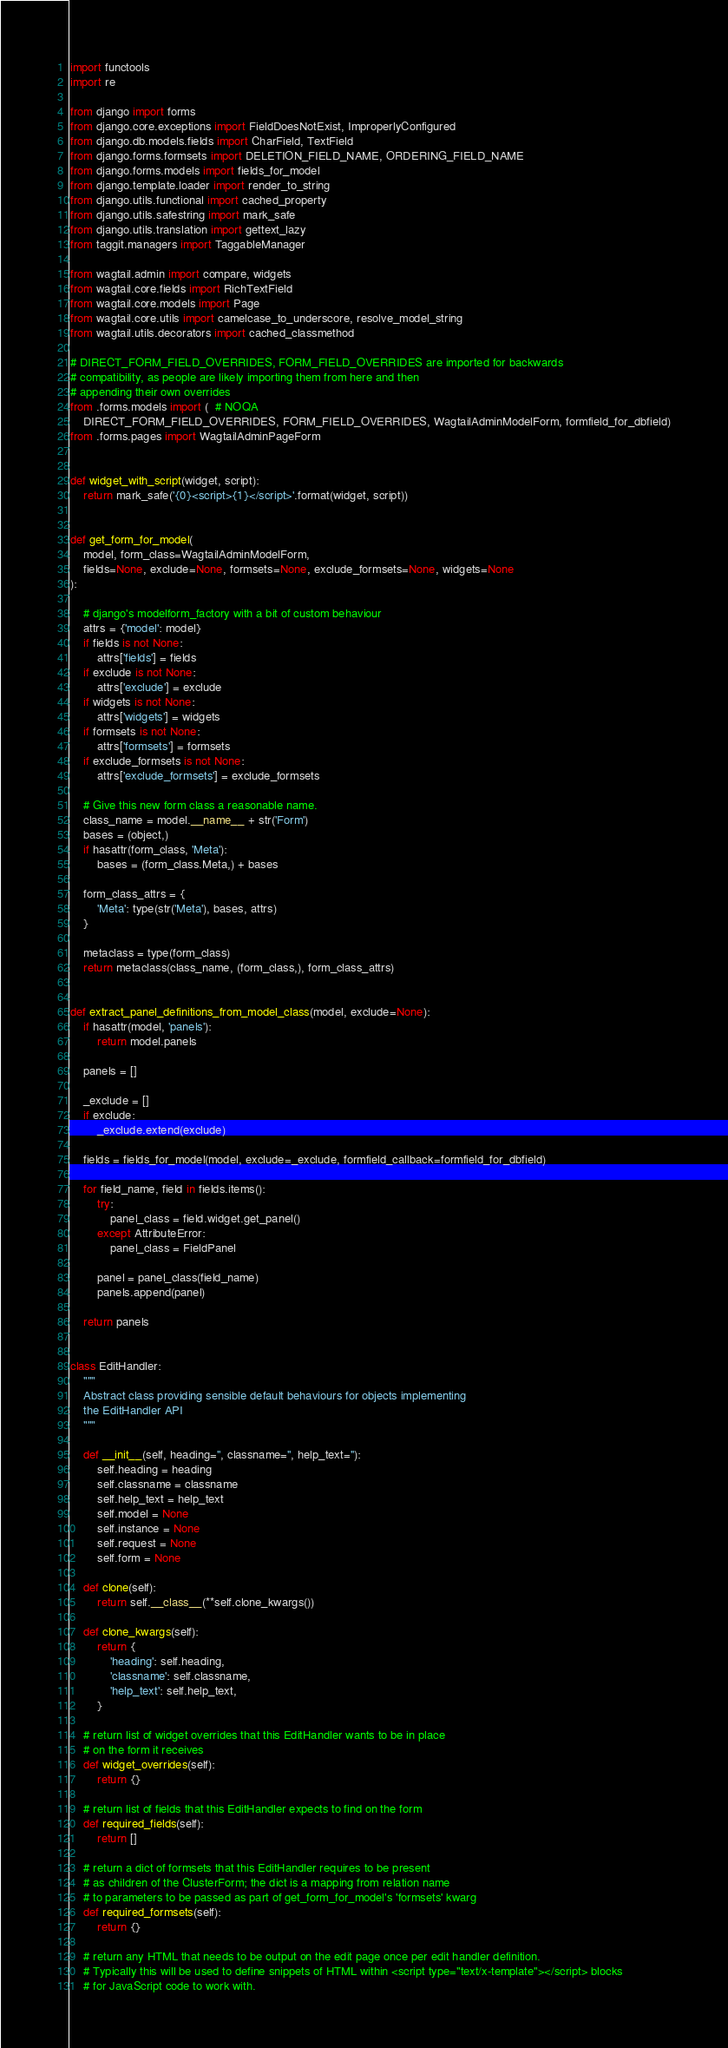Convert code to text. <code><loc_0><loc_0><loc_500><loc_500><_Python_>import functools
import re

from django import forms
from django.core.exceptions import FieldDoesNotExist, ImproperlyConfigured
from django.db.models.fields import CharField, TextField
from django.forms.formsets import DELETION_FIELD_NAME, ORDERING_FIELD_NAME
from django.forms.models import fields_for_model
from django.template.loader import render_to_string
from django.utils.functional import cached_property
from django.utils.safestring import mark_safe
from django.utils.translation import gettext_lazy
from taggit.managers import TaggableManager

from wagtail.admin import compare, widgets
from wagtail.core.fields import RichTextField
from wagtail.core.models import Page
from wagtail.core.utils import camelcase_to_underscore, resolve_model_string
from wagtail.utils.decorators import cached_classmethod

# DIRECT_FORM_FIELD_OVERRIDES, FORM_FIELD_OVERRIDES are imported for backwards
# compatibility, as people are likely importing them from here and then
# appending their own overrides
from .forms.models import (  # NOQA
    DIRECT_FORM_FIELD_OVERRIDES, FORM_FIELD_OVERRIDES, WagtailAdminModelForm, formfield_for_dbfield)
from .forms.pages import WagtailAdminPageForm


def widget_with_script(widget, script):
    return mark_safe('{0}<script>{1}</script>'.format(widget, script))


def get_form_for_model(
    model, form_class=WagtailAdminModelForm,
    fields=None, exclude=None, formsets=None, exclude_formsets=None, widgets=None
):

    # django's modelform_factory with a bit of custom behaviour
    attrs = {'model': model}
    if fields is not None:
        attrs['fields'] = fields
    if exclude is not None:
        attrs['exclude'] = exclude
    if widgets is not None:
        attrs['widgets'] = widgets
    if formsets is not None:
        attrs['formsets'] = formsets
    if exclude_formsets is not None:
        attrs['exclude_formsets'] = exclude_formsets

    # Give this new form class a reasonable name.
    class_name = model.__name__ + str('Form')
    bases = (object,)
    if hasattr(form_class, 'Meta'):
        bases = (form_class.Meta,) + bases

    form_class_attrs = {
        'Meta': type(str('Meta'), bases, attrs)
    }

    metaclass = type(form_class)
    return metaclass(class_name, (form_class,), form_class_attrs)


def extract_panel_definitions_from_model_class(model, exclude=None):
    if hasattr(model, 'panels'):
        return model.panels

    panels = []

    _exclude = []
    if exclude:
        _exclude.extend(exclude)

    fields = fields_for_model(model, exclude=_exclude, formfield_callback=formfield_for_dbfield)

    for field_name, field in fields.items():
        try:
            panel_class = field.widget.get_panel()
        except AttributeError:
            panel_class = FieldPanel

        panel = panel_class(field_name)
        panels.append(panel)

    return panels


class EditHandler:
    """
    Abstract class providing sensible default behaviours for objects implementing
    the EditHandler API
    """

    def __init__(self, heading='', classname='', help_text=''):
        self.heading = heading
        self.classname = classname
        self.help_text = help_text
        self.model = None
        self.instance = None
        self.request = None
        self.form = None

    def clone(self):
        return self.__class__(**self.clone_kwargs())

    def clone_kwargs(self):
        return {
            'heading': self.heading,
            'classname': self.classname,
            'help_text': self.help_text,
        }

    # return list of widget overrides that this EditHandler wants to be in place
    # on the form it receives
    def widget_overrides(self):
        return {}

    # return list of fields that this EditHandler expects to find on the form
    def required_fields(self):
        return []

    # return a dict of formsets that this EditHandler requires to be present
    # as children of the ClusterForm; the dict is a mapping from relation name
    # to parameters to be passed as part of get_form_for_model's 'formsets' kwarg
    def required_formsets(self):
        return {}

    # return any HTML that needs to be output on the edit page once per edit handler definition.
    # Typically this will be used to define snippets of HTML within <script type="text/x-template"></script> blocks
    # for JavaScript code to work with.</code> 